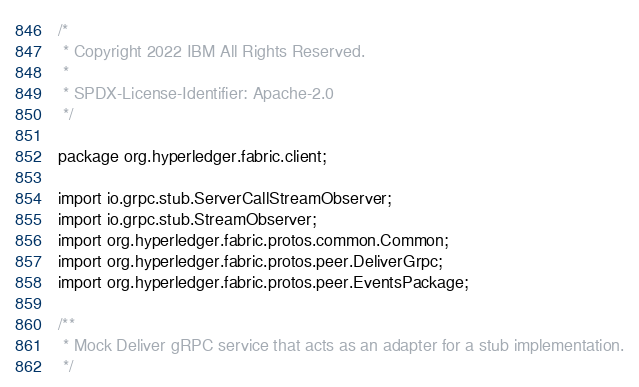Convert code to text. <code><loc_0><loc_0><loc_500><loc_500><_Java_>/*
 * Copyright 2022 IBM All Rights Reserved.
 *
 * SPDX-License-Identifier: Apache-2.0
 */

package org.hyperledger.fabric.client;

import io.grpc.stub.ServerCallStreamObserver;
import io.grpc.stub.StreamObserver;
import org.hyperledger.fabric.protos.common.Common;
import org.hyperledger.fabric.protos.peer.DeliverGrpc;
import org.hyperledger.fabric.protos.peer.EventsPackage;

/**
 * Mock Deliver gRPC service that acts as an adapter for a stub implementation.
 */</code> 